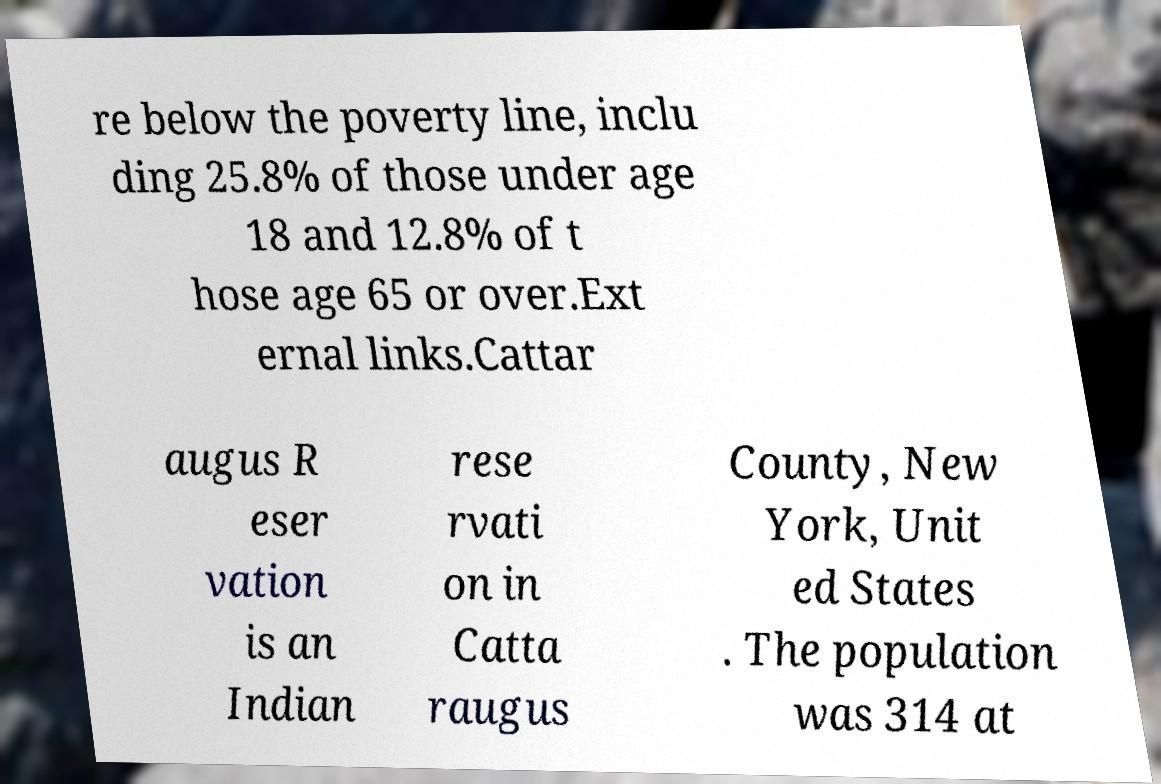Could you extract and type out the text from this image? re below the poverty line, inclu ding 25.8% of those under age 18 and 12.8% of t hose age 65 or over.Ext ernal links.Cattar augus R eser vation is an Indian rese rvati on in Catta raugus County, New York, Unit ed States . The population was 314 at 